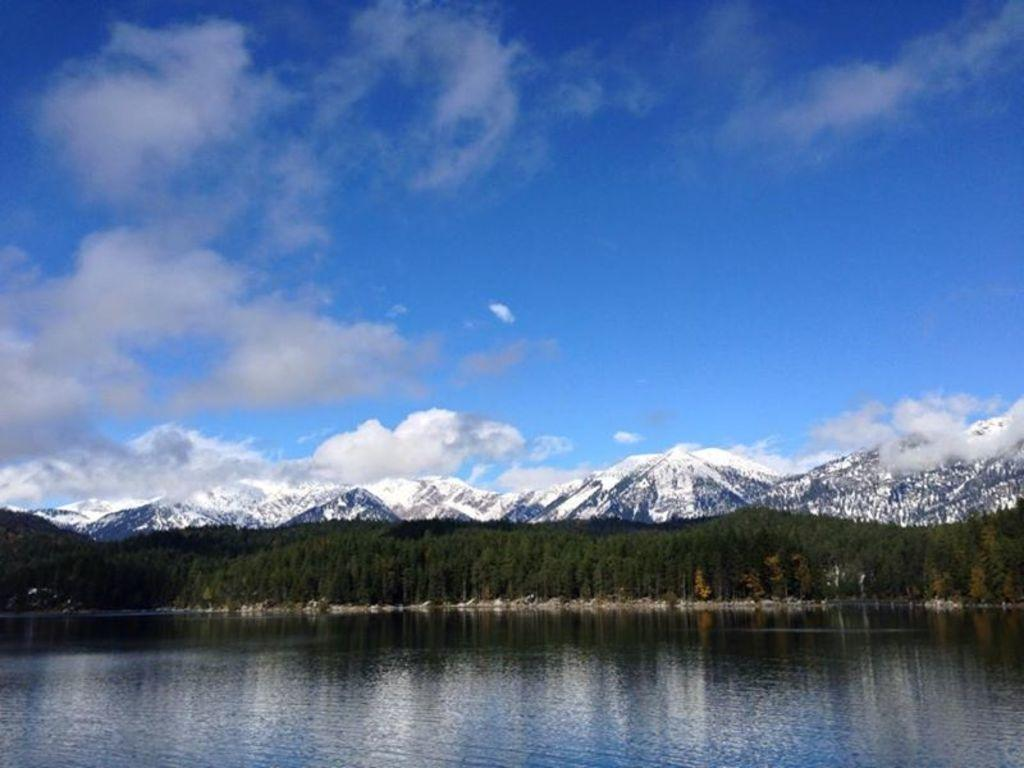What is the main feature of the image? The main feature of the image is a water surface. What can be seen behind the water surface? There are trees behind the water surface. What is located behind the trees? There are mountains behind the trees. How many eggs are visible in the image? There are no eggs visible in the image. 